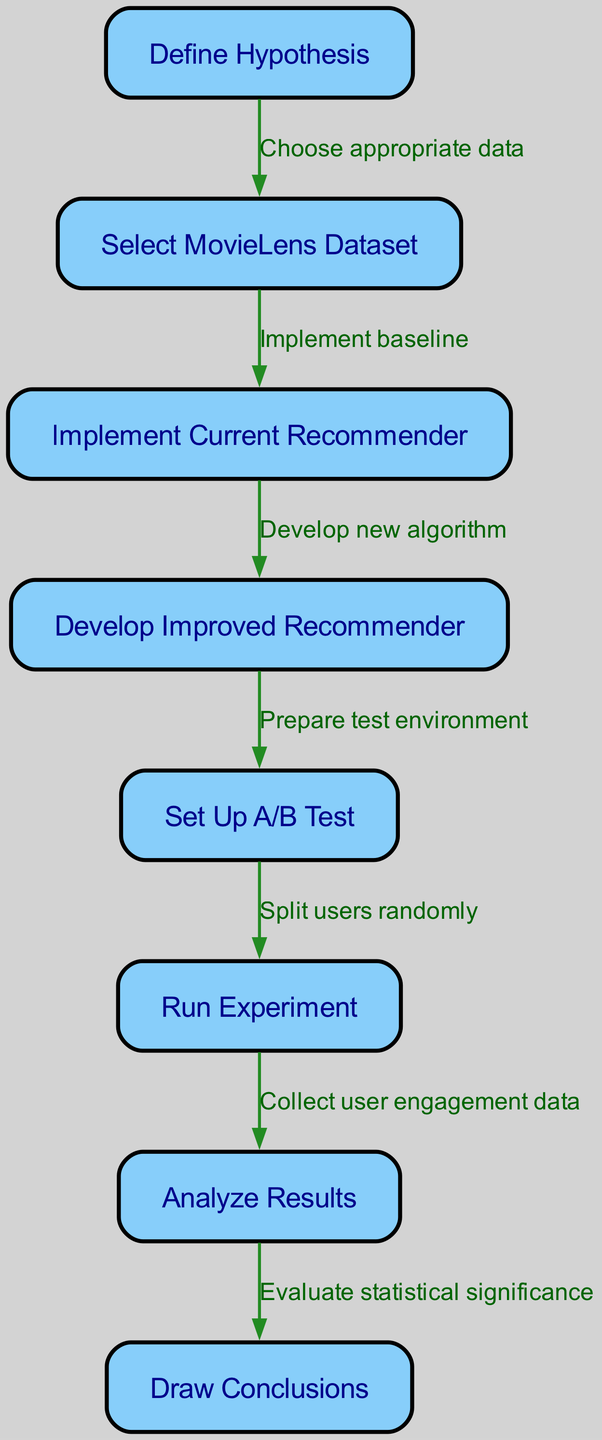What is the first step in the A/B testing process? The first step is "Define Hypothesis", which is the beginning of the process where the core purpose of the A/B test is established.
Answer: Define Hypothesis How many nodes are in the diagram? By counting the nodes listed in the data, there are a total of 8 nodes representing different steps in the A/B testing process.
Answer: 8 What is the relationship between "Select MovieLens Dataset" and "Implement Current Recommender"? The relationship is defined by the edge labeled "Implement baseline", which signifies that selecting the dataset is necessary before implementing the current recommender.
Answer: Implement baseline Which step follows "Run Experiment"? The step that follows "Run Experiment" is "Analyze Results", indicating that after conducting the experiment, the next action is to analyze the collected data and patterns.
Answer: Analyze Results What is required before developing an improved recommender? Before developing an improved recommender, it is necessary to "Implement Current Recommender", which establishes the baseline to compare against the improvements.
Answer: Implement Current Recommender How do you collect data after running the experiment? Data collection occurs at the "Analyze Results" stage where you collect user engagement data that helps in evaluating the experiment outcomes.
Answer: Collect user engagement data What is the final outcome of the A/B testing process? The final outcome of the A/B testing process is "Draw Conclusions", where insights and decisions are made based on the analysis of the experiment's results.
Answer: Draw Conclusions What action is taken after developing the improved recommender? The action taken after developing the improved recommender is to "Set Up A/B Test", which involves preparing the environment for testing the two recommenders against each other.
Answer: Set Up A/B Test How do users get distributed in the A/B test? Users are distributed through the step labeled "Split users randomly", indicating that the assignment to either the current or improved recommender is done randomly for unbiased results.
Answer: Split users randomly 